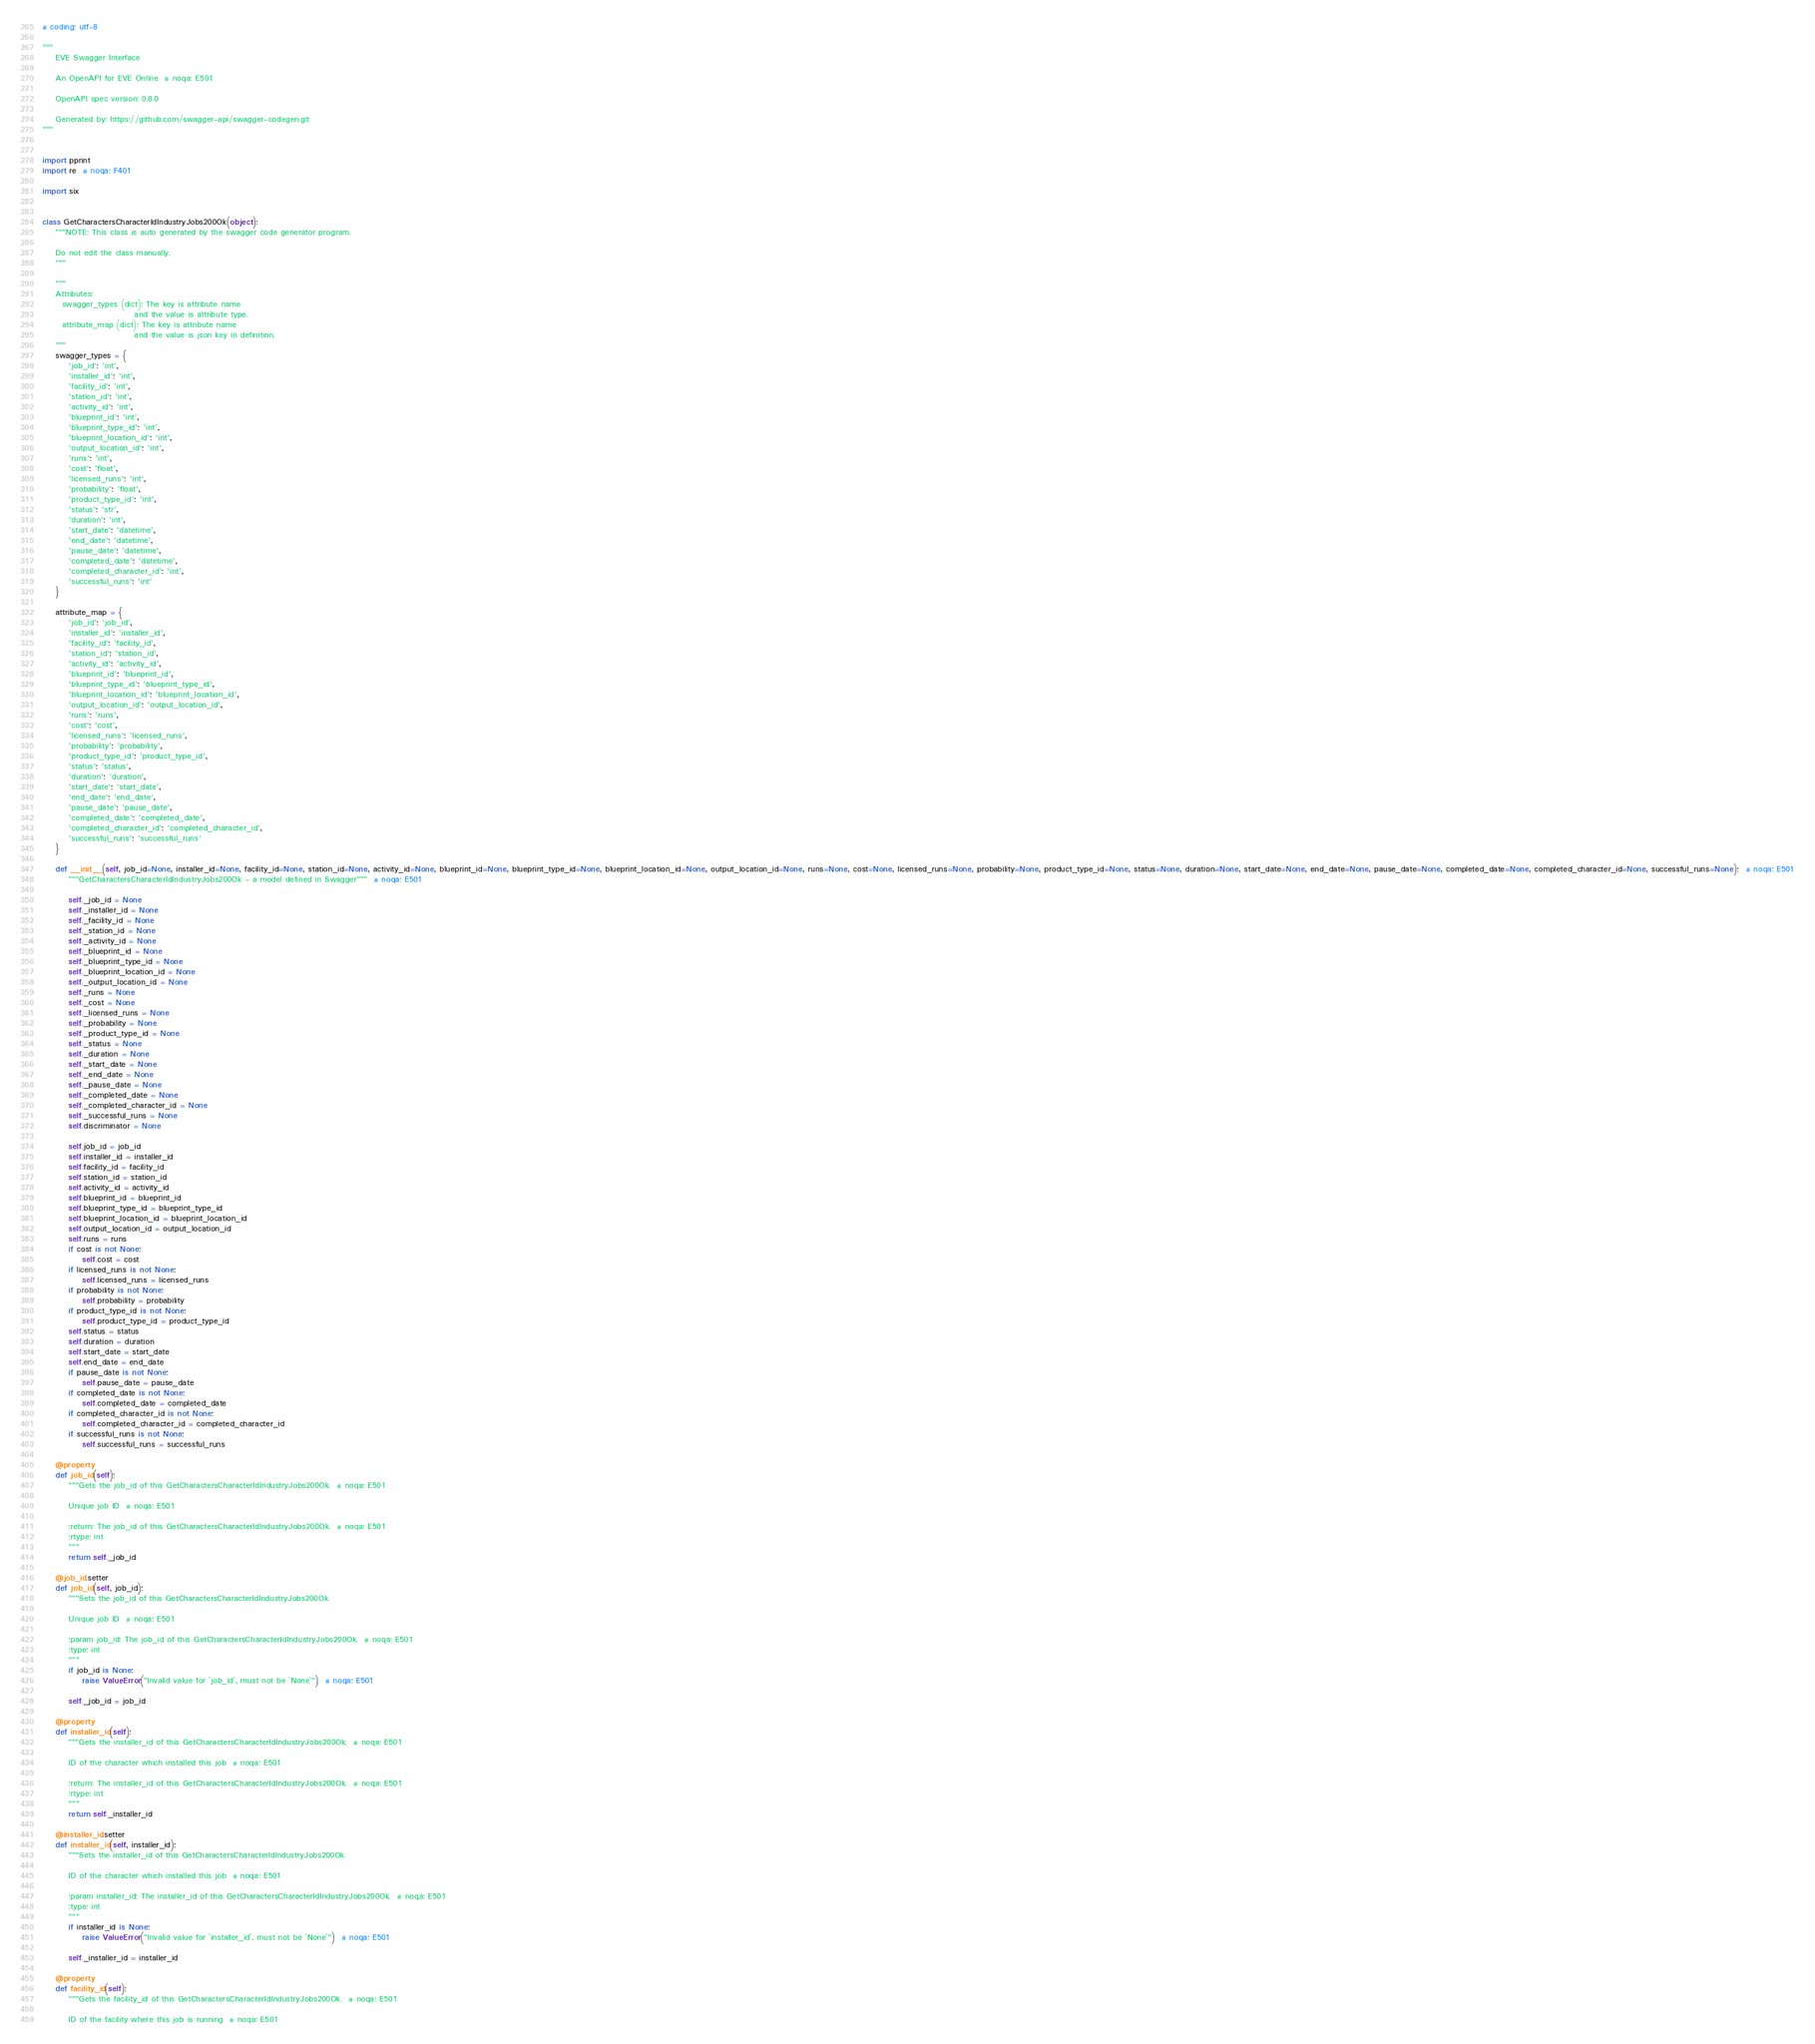Convert code to text. <code><loc_0><loc_0><loc_500><loc_500><_Python_># coding: utf-8

"""
    EVE Swagger Interface

    An OpenAPI for EVE Online  # noqa: E501

    OpenAPI spec version: 0.8.0
    
    Generated by: https://github.com/swagger-api/swagger-codegen.git
"""


import pprint
import re  # noqa: F401

import six


class GetCharactersCharacterIdIndustryJobs200Ok(object):
    """NOTE: This class is auto generated by the swagger code generator program.

    Do not edit the class manually.
    """

    """
    Attributes:
      swagger_types (dict): The key is attribute name
                            and the value is attribute type.
      attribute_map (dict): The key is attribute name
                            and the value is json key in definition.
    """
    swagger_types = {
        'job_id': 'int',
        'installer_id': 'int',
        'facility_id': 'int',
        'station_id': 'int',
        'activity_id': 'int',
        'blueprint_id': 'int',
        'blueprint_type_id': 'int',
        'blueprint_location_id': 'int',
        'output_location_id': 'int',
        'runs': 'int',
        'cost': 'float',
        'licensed_runs': 'int',
        'probability': 'float',
        'product_type_id': 'int',
        'status': 'str',
        'duration': 'int',
        'start_date': 'datetime',
        'end_date': 'datetime',
        'pause_date': 'datetime',
        'completed_date': 'datetime',
        'completed_character_id': 'int',
        'successful_runs': 'int'
    }

    attribute_map = {
        'job_id': 'job_id',
        'installer_id': 'installer_id',
        'facility_id': 'facility_id',
        'station_id': 'station_id',
        'activity_id': 'activity_id',
        'blueprint_id': 'blueprint_id',
        'blueprint_type_id': 'blueprint_type_id',
        'blueprint_location_id': 'blueprint_location_id',
        'output_location_id': 'output_location_id',
        'runs': 'runs',
        'cost': 'cost',
        'licensed_runs': 'licensed_runs',
        'probability': 'probability',
        'product_type_id': 'product_type_id',
        'status': 'status',
        'duration': 'duration',
        'start_date': 'start_date',
        'end_date': 'end_date',
        'pause_date': 'pause_date',
        'completed_date': 'completed_date',
        'completed_character_id': 'completed_character_id',
        'successful_runs': 'successful_runs'
    }

    def __init__(self, job_id=None, installer_id=None, facility_id=None, station_id=None, activity_id=None, blueprint_id=None, blueprint_type_id=None, blueprint_location_id=None, output_location_id=None, runs=None, cost=None, licensed_runs=None, probability=None, product_type_id=None, status=None, duration=None, start_date=None, end_date=None, pause_date=None, completed_date=None, completed_character_id=None, successful_runs=None):  # noqa: E501
        """GetCharactersCharacterIdIndustryJobs200Ok - a model defined in Swagger"""  # noqa: E501

        self._job_id = None
        self._installer_id = None
        self._facility_id = None
        self._station_id = None
        self._activity_id = None
        self._blueprint_id = None
        self._blueprint_type_id = None
        self._blueprint_location_id = None
        self._output_location_id = None
        self._runs = None
        self._cost = None
        self._licensed_runs = None
        self._probability = None
        self._product_type_id = None
        self._status = None
        self._duration = None
        self._start_date = None
        self._end_date = None
        self._pause_date = None
        self._completed_date = None
        self._completed_character_id = None
        self._successful_runs = None
        self.discriminator = None

        self.job_id = job_id
        self.installer_id = installer_id
        self.facility_id = facility_id
        self.station_id = station_id
        self.activity_id = activity_id
        self.blueprint_id = blueprint_id
        self.blueprint_type_id = blueprint_type_id
        self.blueprint_location_id = blueprint_location_id
        self.output_location_id = output_location_id
        self.runs = runs
        if cost is not None:
            self.cost = cost
        if licensed_runs is not None:
            self.licensed_runs = licensed_runs
        if probability is not None:
            self.probability = probability
        if product_type_id is not None:
            self.product_type_id = product_type_id
        self.status = status
        self.duration = duration
        self.start_date = start_date
        self.end_date = end_date
        if pause_date is not None:
            self.pause_date = pause_date
        if completed_date is not None:
            self.completed_date = completed_date
        if completed_character_id is not None:
            self.completed_character_id = completed_character_id
        if successful_runs is not None:
            self.successful_runs = successful_runs

    @property
    def job_id(self):
        """Gets the job_id of this GetCharactersCharacterIdIndustryJobs200Ok.  # noqa: E501

        Unique job ID  # noqa: E501

        :return: The job_id of this GetCharactersCharacterIdIndustryJobs200Ok.  # noqa: E501
        :rtype: int
        """
        return self._job_id

    @job_id.setter
    def job_id(self, job_id):
        """Sets the job_id of this GetCharactersCharacterIdIndustryJobs200Ok.

        Unique job ID  # noqa: E501

        :param job_id: The job_id of this GetCharactersCharacterIdIndustryJobs200Ok.  # noqa: E501
        :type: int
        """
        if job_id is None:
            raise ValueError("Invalid value for `job_id`, must not be `None`")  # noqa: E501

        self._job_id = job_id

    @property
    def installer_id(self):
        """Gets the installer_id of this GetCharactersCharacterIdIndustryJobs200Ok.  # noqa: E501

        ID of the character which installed this job  # noqa: E501

        :return: The installer_id of this GetCharactersCharacterIdIndustryJobs200Ok.  # noqa: E501
        :rtype: int
        """
        return self._installer_id

    @installer_id.setter
    def installer_id(self, installer_id):
        """Sets the installer_id of this GetCharactersCharacterIdIndustryJobs200Ok.

        ID of the character which installed this job  # noqa: E501

        :param installer_id: The installer_id of this GetCharactersCharacterIdIndustryJobs200Ok.  # noqa: E501
        :type: int
        """
        if installer_id is None:
            raise ValueError("Invalid value for `installer_id`, must not be `None`")  # noqa: E501

        self._installer_id = installer_id

    @property
    def facility_id(self):
        """Gets the facility_id of this GetCharactersCharacterIdIndustryJobs200Ok.  # noqa: E501

        ID of the facility where this job is running  # noqa: E501
</code> 